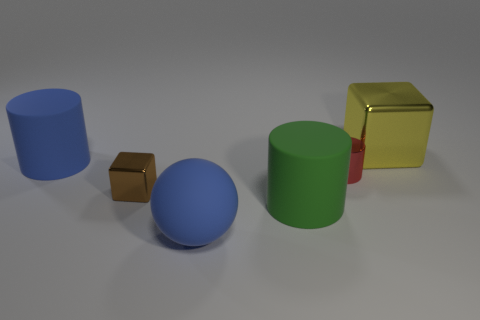Is the color of the thing that is behind the big blue cylinder the same as the large rubber cylinder in front of the tiny brown cube?
Ensure brevity in your answer.  No. Is the green matte thing the same shape as the brown metallic object?
Give a very brief answer. No. Is there any other thing that is the same shape as the red shiny thing?
Provide a short and direct response. Yes. Are the large blue thing that is in front of the green object and the large cube made of the same material?
Your response must be concise. No. There is a large object that is on the right side of the brown metal object and behind the big green matte object; what shape is it?
Provide a succinct answer. Cube. There is a cube in front of the large yellow metallic thing; is there a tiny brown metal cube that is behind it?
Provide a short and direct response. No. What number of other objects are the same material as the large blue cylinder?
Ensure brevity in your answer.  2. Do the large object that is on the right side of the small cylinder and the metal thing that is on the left side of the small red thing have the same shape?
Offer a terse response. Yes. Is the big blue cylinder made of the same material as the green cylinder?
Your response must be concise. Yes. How big is the blue thing right of the large blue object that is to the left of the blue ball in front of the big green rubber cylinder?
Keep it short and to the point. Large. 